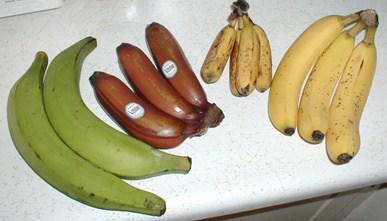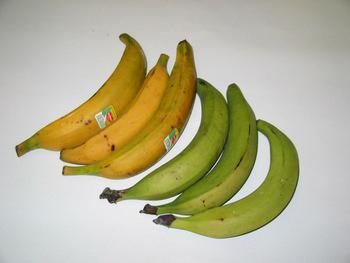The first image is the image on the left, the second image is the image on the right. For the images shown, is this caption "In at least one image there is a single attached group of bananas." true? Answer yes or no. No. The first image is the image on the left, the second image is the image on the right. Given the left and right images, does the statement "All the bananas in the right image are in a bunch." hold true? Answer yes or no. No. 